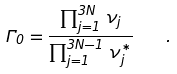<formula> <loc_0><loc_0><loc_500><loc_500>\Gamma _ { 0 } = \frac { \prod _ { j = 1 } ^ { 3 N } \, \nu _ { j } } { \prod _ { j = 1 } ^ { 3 N - 1 } \, \nu _ { j } ^ { * } } \quad .</formula> 